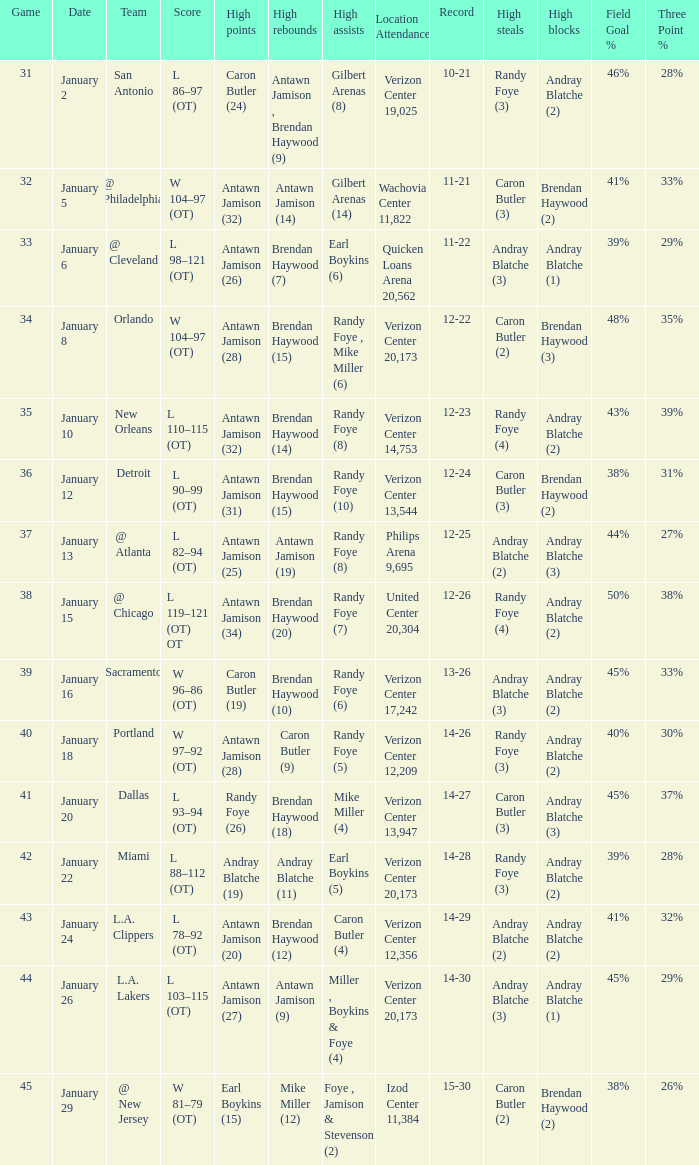What day was the record 14-27? January 20. 